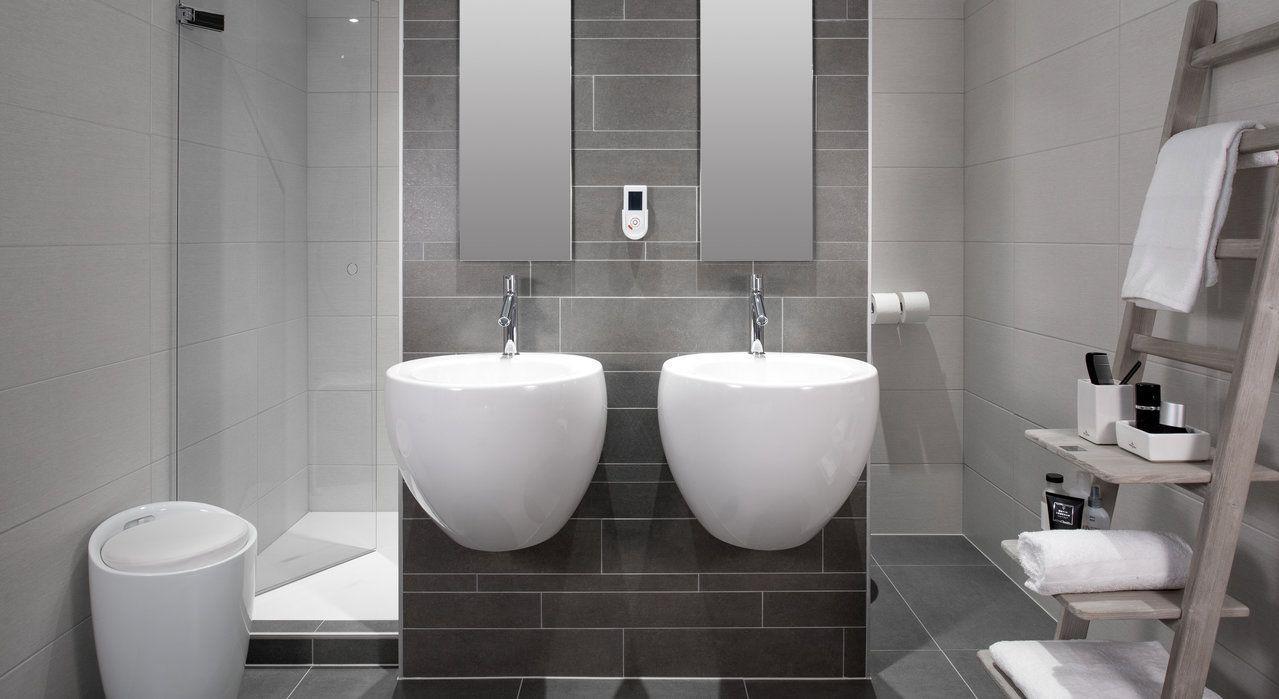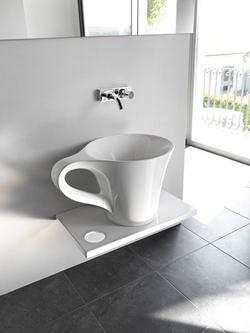The first image is the image on the left, the second image is the image on the right. Evaluate the accuracy of this statement regarding the images: "A sink is in the shape of a cup.". Is it true? Answer yes or no. Yes. 